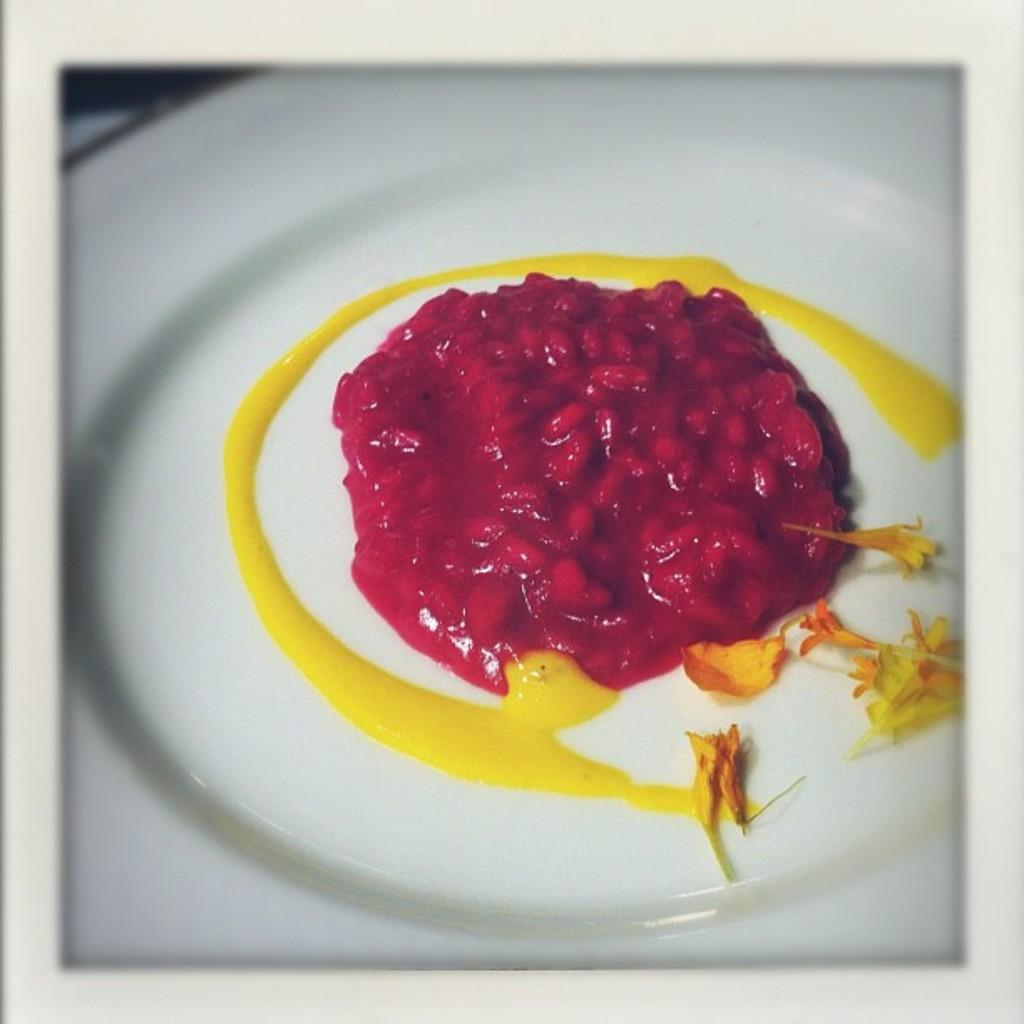Please provide a concise description of this image. In this image I can see a food in the white color plate. Food is in red and yellow color. 